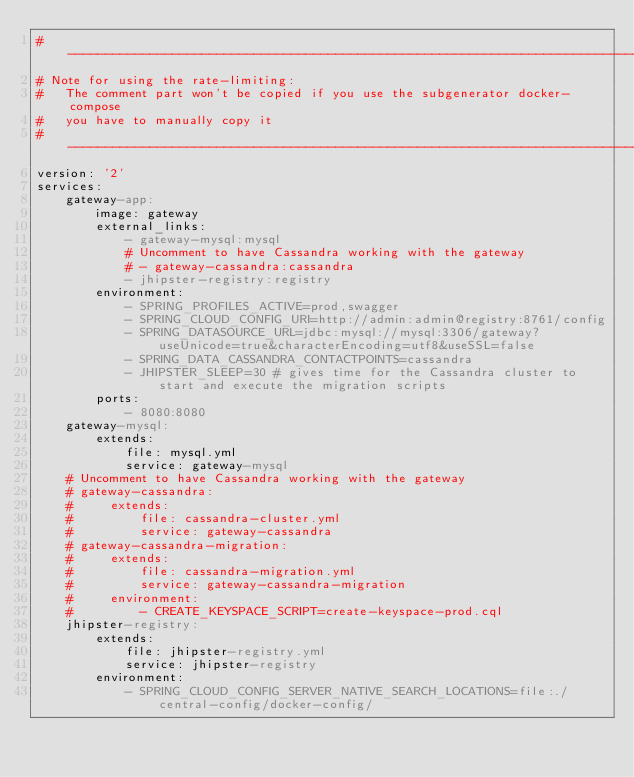Convert code to text. <code><loc_0><loc_0><loc_500><loc_500><_YAML_>#-------------------------------------------------------------------------------
# Note for using the rate-limiting:
#   The comment part won't be copied if you use the subgenerator docker-compose
#   you have to manually copy it
#-------------------------------------------------------------------------------
version: '2'
services:
    gateway-app:
        image: gateway
        external_links:
            - gateway-mysql:mysql
            # Uncomment to have Cassandra working with the gateway
            # - gateway-cassandra:cassandra
            - jhipster-registry:registry
        environment:
            - SPRING_PROFILES_ACTIVE=prod,swagger
            - SPRING_CLOUD_CONFIG_URI=http://admin:admin@registry:8761/config
            - SPRING_DATASOURCE_URL=jdbc:mysql://mysql:3306/gateway?useUnicode=true&characterEncoding=utf8&useSSL=false
            - SPRING_DATA_CASSANDRA_CONTACTPOINTS=cassandra
            - JHIPSTER_SLEEP=30 # gives time for the Cassandra cluster to start and execute the migration scripts
        ports:
            - 8080:8080
    gateway-mysql:
        extends:
            file: mysql.yml
            service: gateway-mysql
    # Uncomment to have Cassandra working with the gateway
    # gateway-cassandra:
    #     extends:
    #         file: cassandra-cluster.yml
    #         service: gateway-cassandra
    # gateway-cassandra-migration:
    #     extends:
    #         file: cassandra-migration.yml
    #         service: gateway-cassandra-migration
    #     environment:
    #         - CREATE_KEYSPACE_SCRIPT=create-keyspace-prod.cql
    jhipster-registry:
        extends:
            file: jhipster-registry.yml
            service: jhipster-registry
        environment:
            - SPRING_CLOUD_CONFIG_SERVER_NATIVE_SEARCH_LOCATIONS=file:./central-config/docker-config/
</code> 